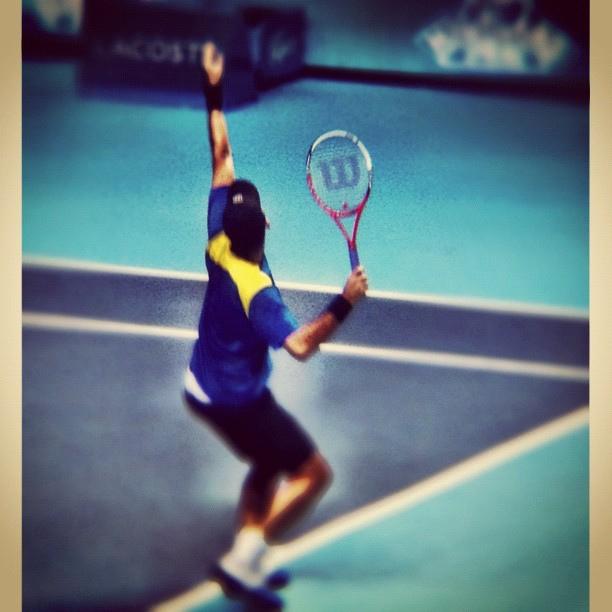What shot is this player making?
Write a very short answer. Serve. What is the name brand of the tennis racket?
Write a very short answer. Wilson. Is this tennis match indoors our outdoors?
Write a very short answer. Indoors. 